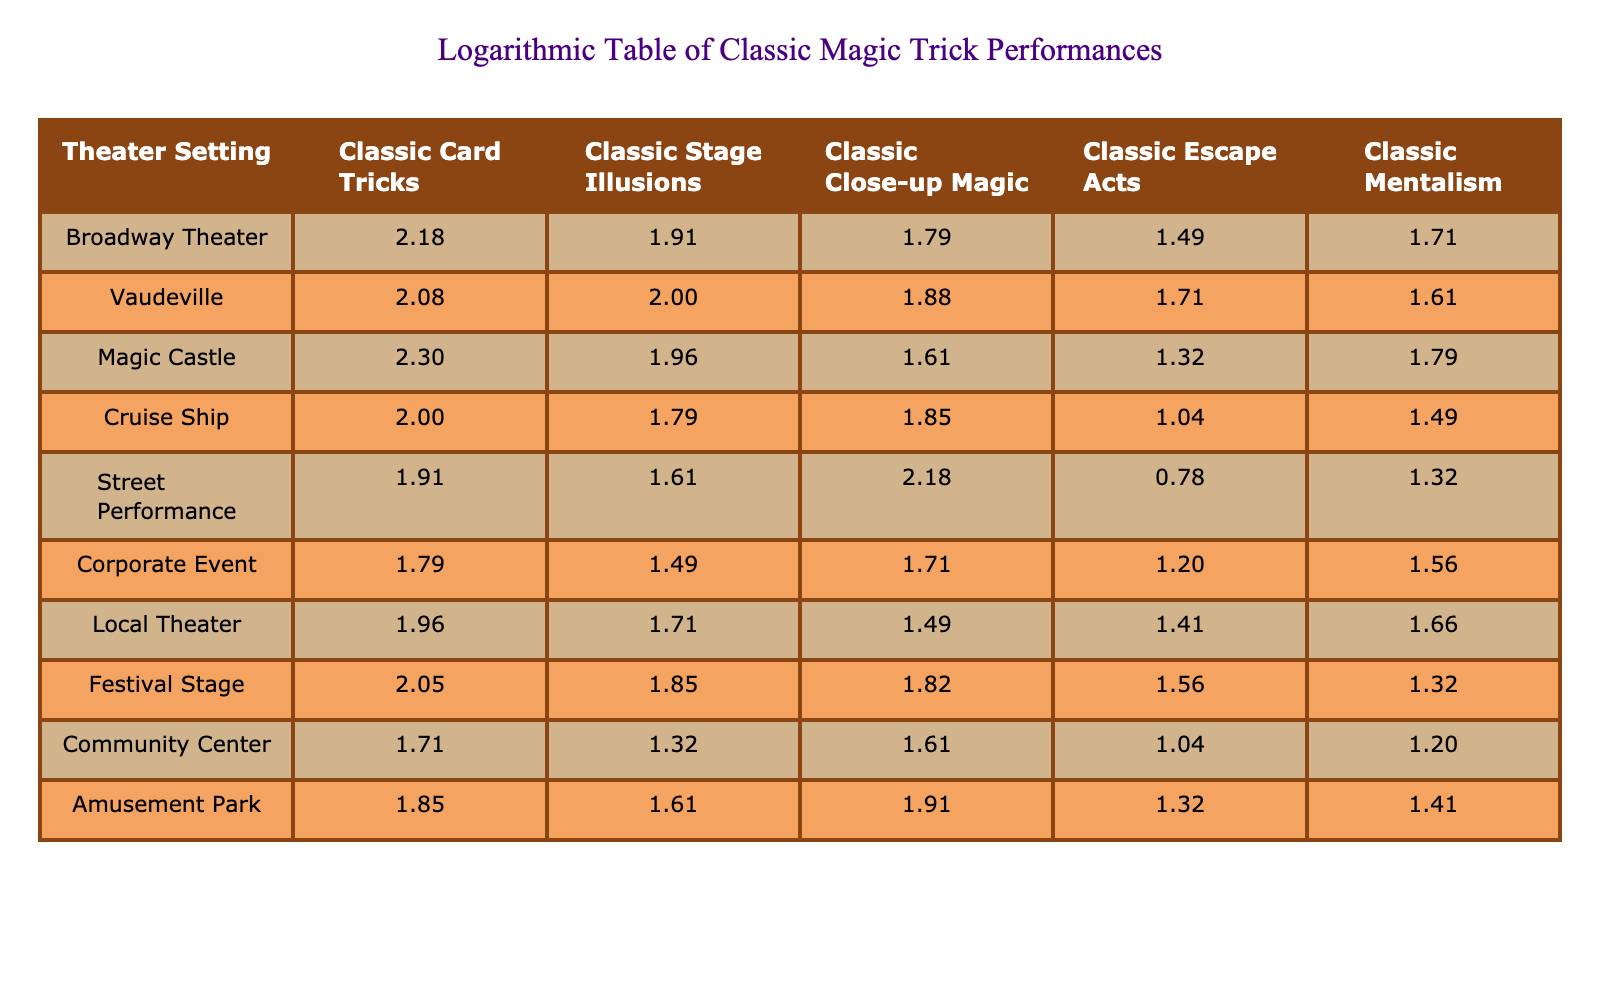What is the highest frequency of Classic Card Tricks performed, and in which theater setting does it occur? The highest frequency of Classic Card Tricks is 200, which occurs in the Magic Castle setting.
Answer: 200, Magic Castle What type of classic magic trick had the lowest performance frequency across all theater settings? Looking at the table, Classic Escape Acts has the lowest frequency, which is 5, noted in the Street Performance setting.
Answer: 5, Street Performance What are the total performances of Classic Close-up Magic across all theater settings? By adding the frequencies of Classic Close-up Magic: 60 + 75 + 40 + 70 + 150 + 50 + 30 + 65 + 40 + 80 = 720.
Answer: 720 Is it true that Corporate Events have more Classic Mentalism performances than Classic Close-up Magic performances? Corporate Events show 35 performances for Classic Mentalism and 50 for Classic Close-up Magic, so the statement is false.
Answer: No What is the difference in frequency of Classic Stage Illusions between the Broadway Theater and Vaudeville? The frequency for Broadway Theater is 80 and for Vaudeville it is 100, thus the difference is 100 - 80 = 20.
Answer: 20 What is the average frequency of Classic Magic performances in the Local Theater setting? The performances in Local Theater are: 90 (Card Tricks), 50 (Stage Illusions), 30 (Close-up Magic), 25 (Escape Acts), 45 (Mentalism). Their total is 90 + 50 + 30 + 25 + 45 = 240, and the average is 240/5 = 48.
Answer: 48 Which theater setting has the highest performances for Classic Mentalism and what is the frequency? The highest frequency for Classic Mentalism is 60, found in the Magic Castle setting.
Answer: 60, Magic Castle In the Festival Stage, how many more Classic Card Tricks are performed than Classic Close-up Magic? The frequency of Classic Card Tricks is 110 and Classic Close-up Magic is 65, so the difference is 110 - 65 = 45.
Answer: 45 